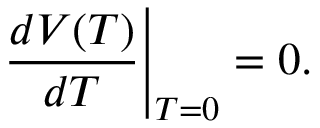<formula> <loc_0><loc_0><loc_500><loc_500>\frac { d V ( T ) } { d T } \right | _ { T = 0 } = 0 .</formula> 